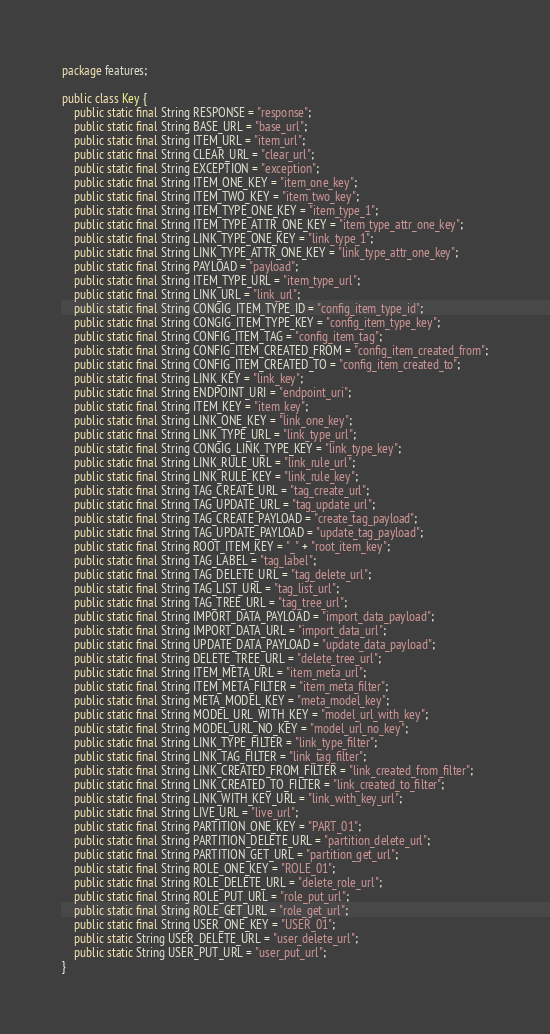<code> <loc_0><loc_0><loc_500><loc_500><_Java_>package features;

public class Key {
    public static final String RESPONSE = "response";
    public static final String BASE_URL = "base_url";
    public static final String ITEM_URL = "item_url";
    public static final String CLEAR_URL = "clear_url";
    public static final String EXCEPTION = "exception";
    public static final String ITEM_ONE_KEY = "item_one_key";
    public static final String ITEM_TWO_KEY = "item_two_key";
    public static final String ITEM_TYPE_ONE_KEY = "item_type_1";
    public static final String ITEM_TYPE_ATTR_ONE_KEY = "item_type_attr_one_key";
    public static final String LINK_TYPE_ONE_KEY = "link_type_1";
    public static final String LINK_TYPE_ATTR_ONE_KEY = "link_type_attr_one_key";
    public static final String PAYLOAD = "payload";
    public static final String ITEM_TYPE_URL = "item_type_url";
    public static final String LINK_URL = "link_url";
    public static final String CONGIG_ITEM_TYPE_ID = "config_item_type_id";
    public static final String CONGIG_ITEM_TYPE_KEY = "config_item_type_key";
    public static final String CONFIG_ITEM_TAG = "config_item_tag";
    public static final String CONFIG_ITEM_CREATED_FROM = "config_item_created_from";
    public static final String CONFIG_ITEM_CREATED_TO = "config_item_created_to";
    public static final String LINK_KEY = "link_key";
    public static final String ENDPOINT_URI = "endpoint_uri";
    public static final String ITEM_KEY = "item_key";
    public static final String LINK_ONE_KEY = "link_one_key";
    public static final String LINK_TYPE_URL = "link_type_url";
    public static final String CONGIG_LINK_TYPE_KEY = "link_type_key";
    public static final String LINK_RULE_URL = "link_rule_url";
    public static final String LINK_RULE_KEY = "link_rule_key";
    public static final String TAG_CREATE_URL = "tag_create_url";
    public static final String TAG_UPDATE_URL = "tag_update_url";
    public static final String TAG_CREATE_PAYLOAD = "create_tag_payload";
    public static final String TAG_UPDATE_PAYLOAD = "update_tag_payload";
    public static final String ROOT_ITEM_KEY = "_" + "root_item_key";
    public static final String TAG_LABEL = "tag_label";
    public static final String TAG_DELETE_URL = "tag_delete_url";
    public static final String TAG_LIST_URL = "tag_list_url";
    public static final String TAG_TREE_URL = "tag_tree_url";
    public static final String IMPORT_DATA_PAYLOAD = "import_data_payload";
    public static final String IMPORT_DATA_URL = "import_data_url";
    public static final String UPDATE_DATA_PAYLOAD = "update_data_payload";
    public static final String DELETE_TREE_URL = "delete_tree_url";
    public static final String ITEM_META_URL = "item_meta_url";
    public static final String ITEM_META_FILTER = "item_meta_filter";
    public static final String META_MODEL_KEY = "meta_model_key";
    public static final String MODEL_URL_WITH_KEY = "model_url_with_key";
    public static final String MODEL_URL_NO_KEY = "model_url_no_key";
    public static final String LINK_TYPE_FILTER = "link_type_filter";
    public static final String LINK_TAG_FILTER = "link_tag_filter";
    public static final String LINK_CREATED_FROM_FILTER = "link_created_from_filter";
    public static final String LINK_CREATED_TO_FILTER = "link_created_to_filter";
    public static final String LINK_WITH_KEY_URL = "link_with_key_url";
    public static final String LIVE_URL = "live_url";
    public static final String PARTITION_ONE_KEY = "PART_01";
    public static final String PARTITION_DELETE_URL = "partition_delete_url";
    public static final String PARTITION_GET_URL = "partition_get_url";
    public static final String ROLE_ONE_KEY = "ROLE_01";
    public static final String ROLE_DELETE_URL = "delete_role_url";
    public static final String ROLE_PUT_URL = "role_put_url";
    public static final String ROLE_GET_URL = "role_get_url";
    public static final String USER_ONE_KEY = "USER_01";
    public static String USER_DELETE_URL = "user_delete_url";
    public static String USER_PUT_URL = "user_put_url";
}

</code> 